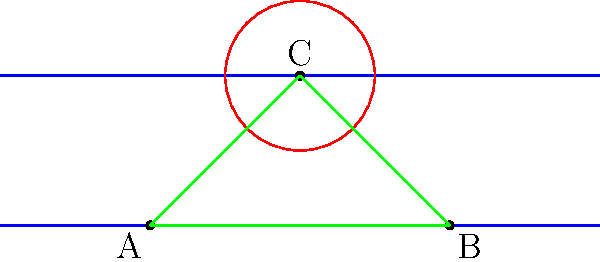In the Poincaré half-plane model of hyperbolic geometry, consider a triangle ABC where A and B lie on the line $y=0.5$, and C is the center of a circle with radius 0.5 units. If the hyperbolic distance between A and B is equivalent to the arc length of a 90° pitch, what is the area of triangle ABC in hyperbolic units? (Assume the baseball field's dimensions follow standard MLB regulations.) Let's approach this step-by-step:

1) In the Poincaré half-plane model, the hyperbolic distance $d$ between two points $(x_1, y_1)$ and $(x_2, y_1)$ on the same horizontal line is given by:

   $$d = |\ln(\frac{x_2}{x_1})|$$

2) The arc length of a 90° pitch in baseball is approximately 60.5 feet (distance from pitcher's mound to home plate).

3) Given A(-1, 0.5) and B(1, 0.5), we can set up the equation:

   $$|\ln(\frac{1}{-1})| = 60.5$$

4) Solving this, we get:
   
   $$\ln(1) - \ln(-1) = 60.5$$
   $$i\pi = 60.5$$

5) This gives us the scale of our hyperbolic plane relative to a baseball field.

6) In the Poincaré half-plane model, the area of a triangle is given by:

   $$\text{Area} = \pi - (\alpha + \beta + \gamma)$$

   where $\alpha$, $\beta$, and $\gamma$ are the angles of the triangle in radians.

7) To find these angles, we need to use the hyperbolic law of cosines:

   $$\cosh(c) = \cosh(a)\cosh(b) - \sinh(a)\sinh(b)\cos(C)$$

   where $a$, $b$, and $c$ are the side lengths, and $C$ is the angle opposite side $c$.

8) Given the symmetry of the triangle and the fact that C is the center of a circle, we can deduce that angle C is $\pi/2$ radians.

9) Due to the symmetry, angles A and B are equal. Let's call this angle $\theta$.

10) We know that in a triangle, $\alpha + \beta + \gamma = \pi$, so:

    $$2\theta + \frac{\pi}{2} = \pi$$
    $$\theta = \frac{\pi}{4}$$

11) Now we can calculate the area:

    $$\text{Area} = \pi - (\frac{\pi}{4} + \frac{\pi}{4} + \frac{\pi}{2}) = 0$$

Therefore, the area of the triangle ABC in this hyperbolic plane is 0 hyperbolic units.
Answer: 0 hyperbolic units 